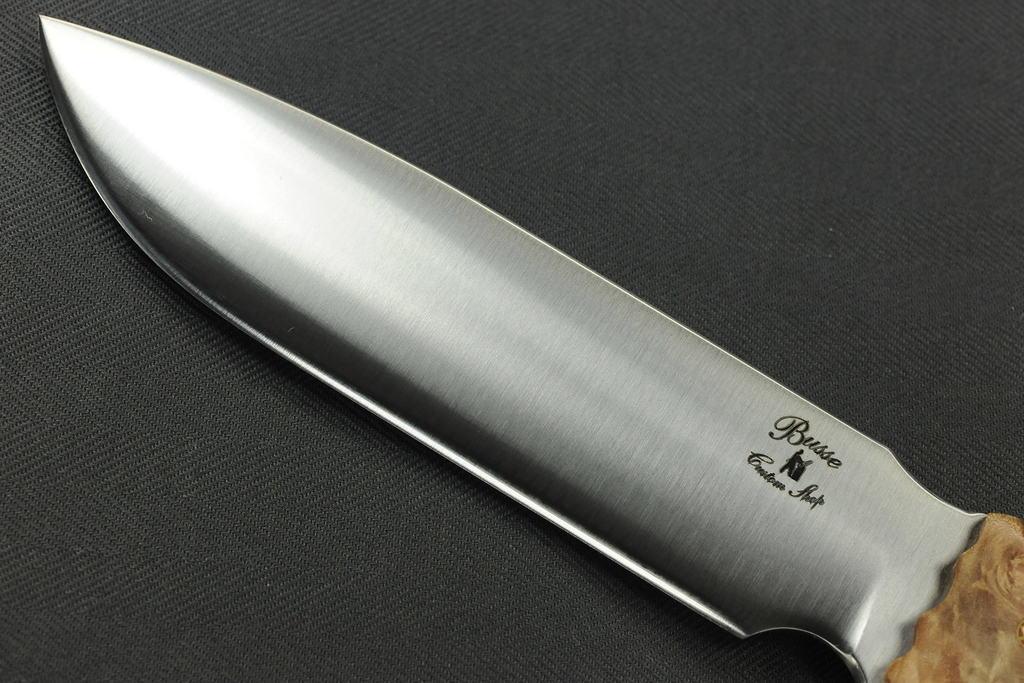Could you give a brief overview of what you see in this image? In this image, we can see a steel knife on the black surface. 